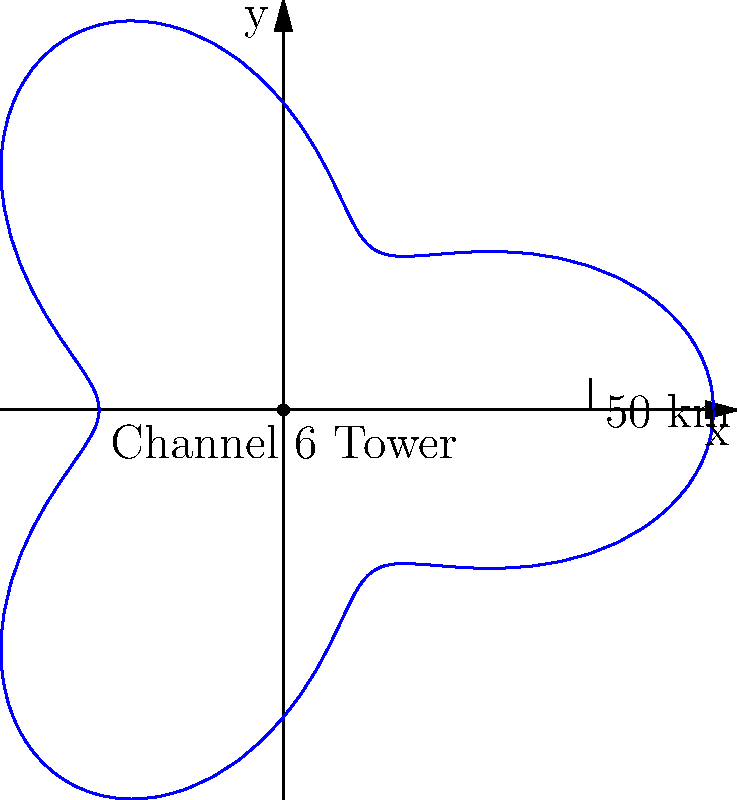Channel 6's broadcast tower has a coverage area that can be modeled using the polar equation $r = 50 + 20\cos(3\theta)$, where $r$ is in kilometers. What is the maximum range of the broadcast signal in kilometers? To find the maximum range of the broadcast signal, we need to follow these steps:

1) The polar equation given is $r = 50 + 20\cos(3\theta)$.

2) The maximum value of $\cos(3\theta)$ is 1, which occurs when $3\theta = 0, 2\pi, 4\pi,$ etc.

3) The minimum value of $\cos(3\theta)$ is -1, which occurs when $3\theta = \pi, 3\pi, 5\pi,$ etc.

4) When $\cos(3\theta) = 1$, we get the maximum value of $r$:

   $r_{max} = 50 + 20(1) = 70$ km

5) When $\cos(3\theta) = -1$, we get the minimum value of $r$:

   $r_{min} = 50 + 20(-1) = 30$ km

6) The maximum range is the largest value of $r$, which is 70 km.
Answer: 70 km 